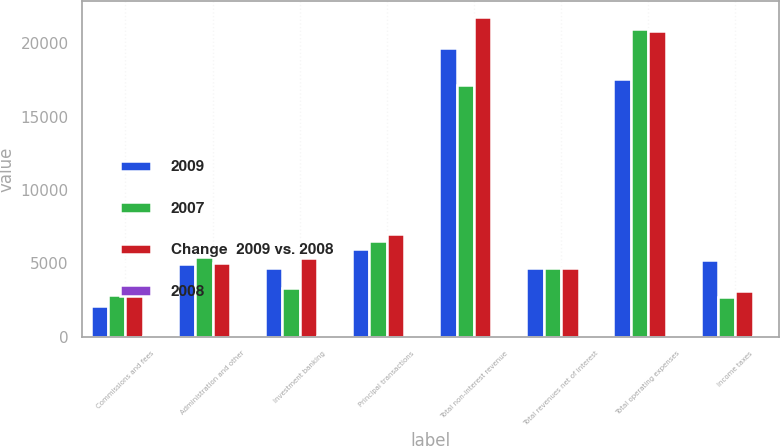<chart> <loc_0><loc_0><loc_500><loc_500><stacked_bar_chart><ecel><fcel>Commissions and fees<fcel>Administration and other<fcel>Investment banking<fcel>Principal transactions<fcel>Total non-interest revenue<fcel>Total revenues net of interest<fcel>Total operating expenses<fcel>Income taxes<nl><fcel>2009<fcel>2075<fcel>4964<fcel>4685<fcel>6001<fcel>19696<fcel>4685<fcel>17568<fcel>5261<nl><fcel>2007<fcel>2876<fcel>5413<fcel>3329<fcel>6544<fcel>17141<fcel>4685<fcel>20955<fcel>2746<nl><fcel>Change  2009 vs. 2008<fcel>3156<fcel>5014<fcel>5399<fcel>7012<fcel>21750<fcel>4685<fcel>20812<fcel>3116<nl><fcel>2008<fcel>28<fcel>8<fcel>41<fcel>8<fcel>15<fcel>7<fcel>16<fcel>92<nl></chart> 